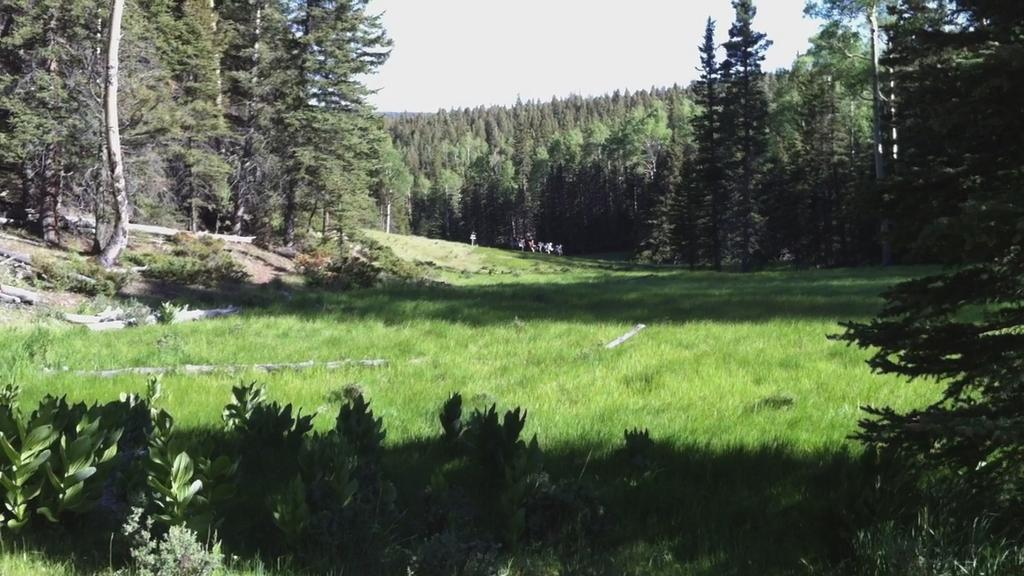What type of vegetation can be seen in the image? There are trees with branches and leaves in the image. What is the color of the grass in the image? The grass is green in color and visible in the image. Are there any other plants besides trees in the image? Yes, there are small bushes in the image. What part of the natural environment is visible in the image? The sky is visible in the image. What type of pleasure can be seen being experienced by the spoon in the image? There is no spoon present in the image, and therefore no pleasure can be observed. 